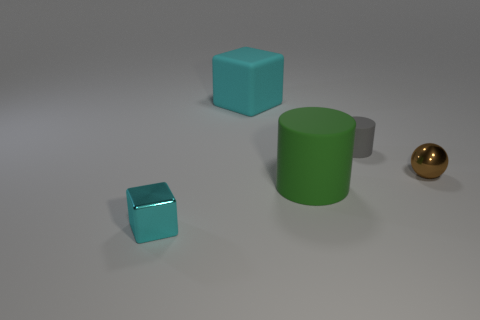Is the number of small brown objects greater than the number of brown metallic blocks?
Keep it short and to the point. Yes. The cyan object that is the same material as the big green object is what size?
Provide a short and direct response. Large. Does the metallic thing that is to the right of the tiny cube have the same size as the metal object that is to the left of the small brown sphere?
Give a very brief answer. Yes. What number of objects are either large objects on the right side of the cyan rubber block or big yellow things?
Keep it short and to the point. 1. Is the number of rubber cylinders less than the number of brown balls?
Offer a very short reply. No. There is a tiny metal thing that is on the right side of the cyan cube that is behind the rubber cylinder that is in front of the sphere; what shape is it?
Give a very brief answer. Sphere. There is a thing that is the same color as the large block; what shape is it?
Make the answer very short. Cube. Is there a large thing?
Your answer should be very brief. Yes. There is a cyan shiny cube; is it the same size as the shiny thing to the right of the tiny cyan cube?
Your answer should be compact. Yes. There is a cube that is in front of the shiny ball; are there any small gray matte cylinders that are on the right side of it?
Provide a succinct answer. Yes. 